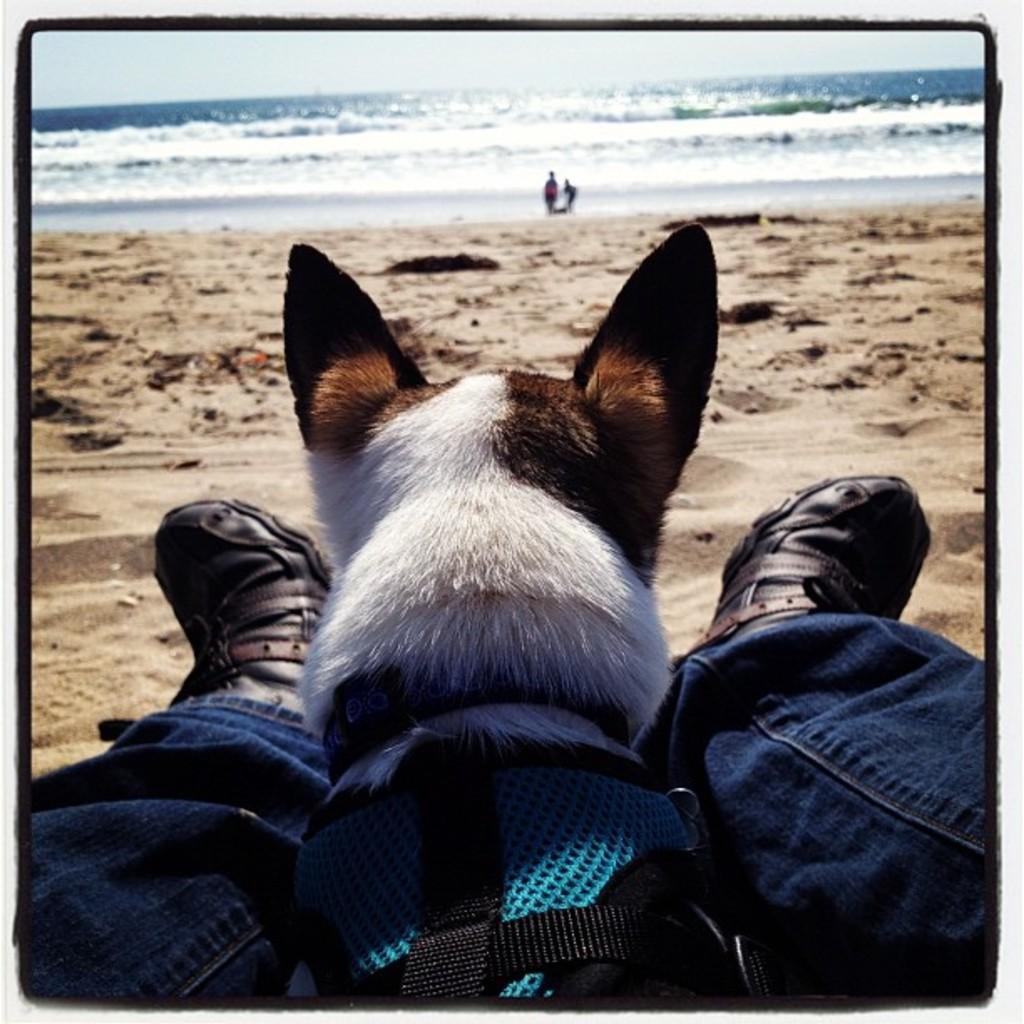Please provide a concise description of this image. In this picture there is a person sitting on the beach side with dog in between both of his legs and there is sand there are two persons standing over here and in the backdrop there is a sea and the sky is clear 